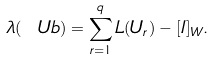Convert formula to latex. <formula><loc_0><loc_0><loc_500><loc_500>\lambda ( \ U b ) = \sum _ { r = 1 } ^ { q } L ( { U _ { r } } ) - [ I ] _ { W } .</formula> 